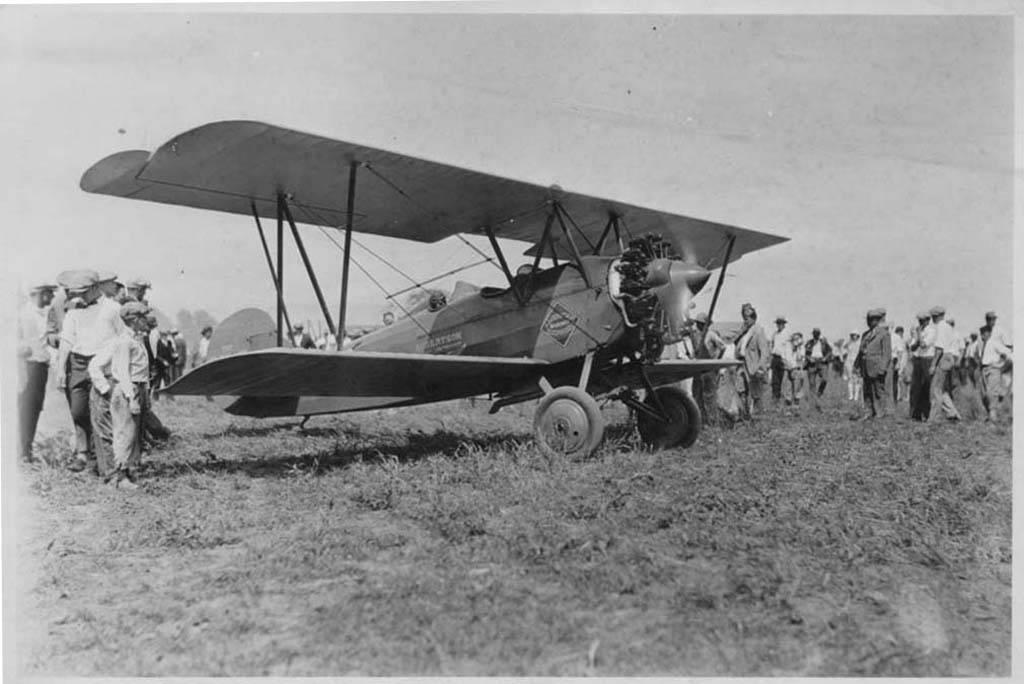What is the main subject of the image? The main subject of the image is an aircraft. What are the people in the image doing? The people in the image are standing. What are the people wearing on their heads? The people are wearing caps on their heads. What type of terrain is visible in the image? There is grass visible on the ground. Are there any other people visible in the image? Yes, there are people standing in the background of the image. Can you see any animals at the seashore in the image? There is no seashore or animals present in the image. What type of animal is giving birth in the image? There is no animal giving birth in the image. 